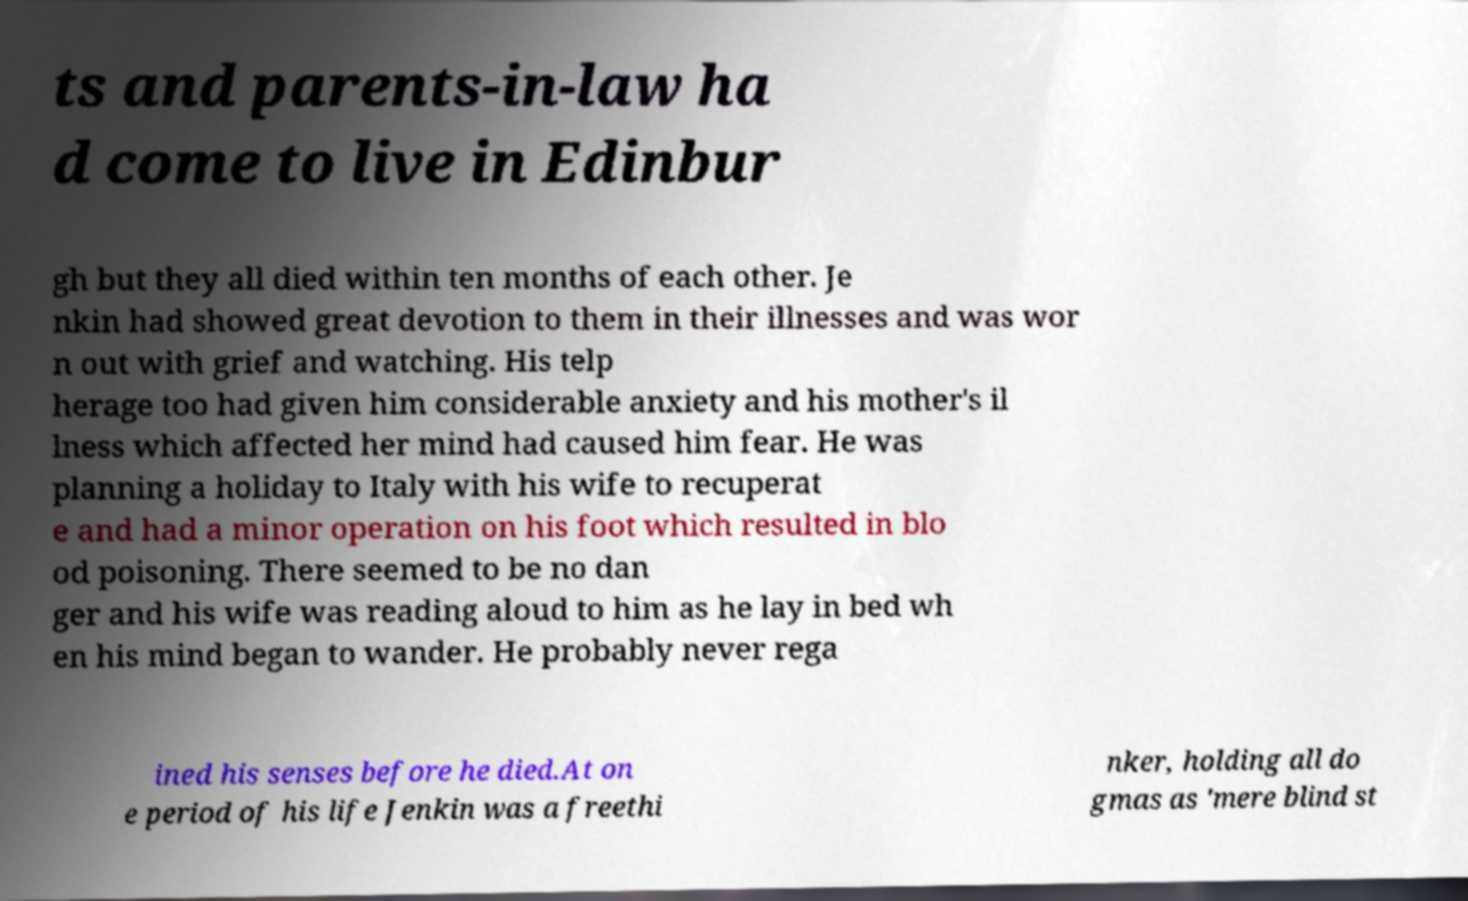I need the written content from this picture converted into text. Can you do that? ts and parents-in-law ha d come to live in Edinbur gh but they all died within ten months of each other. Je nkin had showed great devotion to them in their illnesses and was wor n out with grief and watching. His telp herage too had given him considerable anxiety and his mother's il lness which affected her mind had caused him fear. He was planning a holiday to Italy with his wife to recuperat e and had a minor operation on his foot which resulted in blo od poisoning. There seemed to be no dan ger and his wife was reading aloud to him as he lay in bed wh en his mind began to wander. He probably never rega ined his senses before he died.At on e period of his life Jenkin was a freethi nker, holding all do gmas as 'mere blind st 